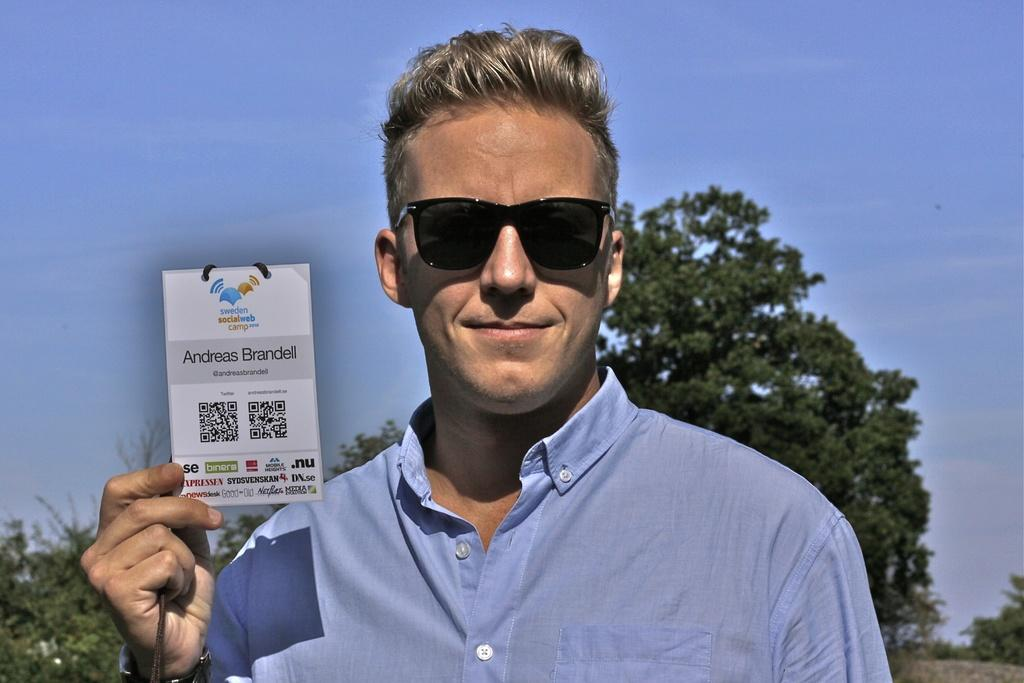What is the main subject of the image? There is a man standing in the center of the image. What is the man holding in the image? The man is holding a card. What can be seen in the background of the image? There are trees and the sky visible in the background of the image. What language is the man speaking to his friend in the morning in the image? There is no indication of the man speaking to a friend or the time of day in the image. The language cannot be determined from the image. 